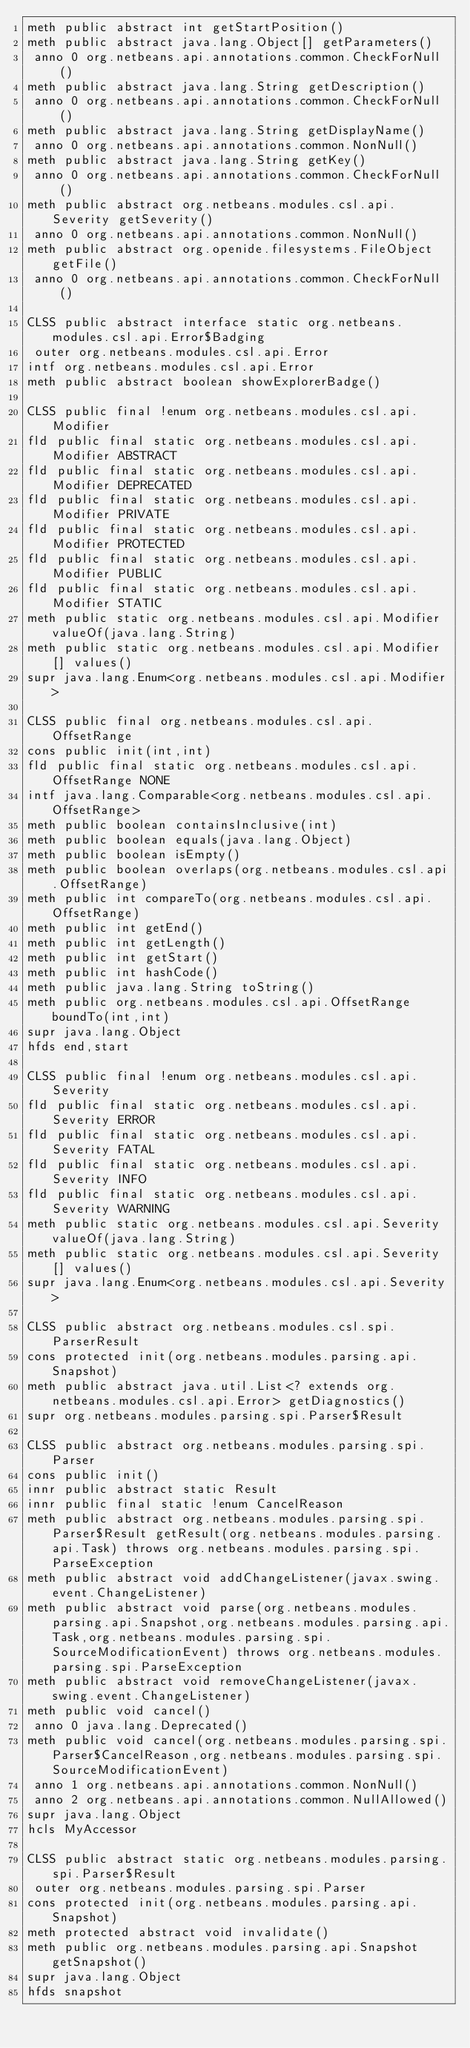Convert code to text. <code><loc_0><loc_0><loc_500><loc_500><_SML_>meth public abstract int getStartPosition()
meth public abstract java.lang.Object[] getParameters()
 anno 0 org.netbeans.api.annotations.common.CheckForNull()
meth public abstract java.lang.String getDescription()
 anno 0 org.netbeans.api.annotations.common.CheckForNull()
meth public abstract java.lang.String getDisplayName()
 anno 0 org.netbeans.api.annotations.common.NonNull()
meth public abstract java.lang.String getKey()
 anno 0 org.netbeans.api.annotations.common.CheckForNull()
meth public abstract org.netbeans.modules.csl.api.Severity getSeverity()
 anno 0 org.netbeans.api.annotations.common.NonNull()
meth public abstract org.openide.filesystems.FileObject getFile()
 anno 0 org.netbeans.api.annotations.common.CheckForNull()

CLSS public abstract interface static org.netbeans.modules.csl.api.Error$Badging
 outer org.netbeans.modules.csl.api.Error
intf org.netbeans.modules.csl.api.Error
meth public abstract boolean showExplorerBadge()

CLSS public final !enum org.netbeans.modules.csl.api.Modifier
fld public final static org.netbeans.modules.csl.api.Modifier ABSTRACT
fld public final static org.netbeans.modules.csl.api.Modifier DEPRECATED
fld public final static org.netbeans.modules.csl.api.Modifier PRIVATE
fld public final static org.netbeans.modules.csl.api.Modifier PROTECTED
fld public final static org.netbeans.modules.csl.api.Modifier PUBLIC
fld public final static org.netbeans.modules.csl.api.Modifier STATIC
meth public static org.netbeans.modules.csl.api.Modifier valueOf(java.lang.String)
meth public static org.netbeans.modules.csl.api.Modifier[] values()
supr java.lang.Enum<org.netbeans.modules.csl.api.Modifier>

CLSS public final org.netbeans.modules.csl.api.OffsetRange
cons public init(int,int)
fld public final static org.netbeans.modules.csl.api.OffsetRange NONE
intf java.lang.Comparable<org.netbeans.modules.csl.api.OffsetRange>
meth public boolean containsInclusive(int)
meth public boolean equals(java.lang.Object)
meth public boolean isEmpty()
meth public boolean overlaps(org.netbeans.modules.csl.api.OffsetRange)
meth public int compareTo(org.netbeans.modules.csl.api.OffsetRange)
meth public int getEnd()
meth public int getLength()
meth public int getStart()
meth public int hashCode()
meth public java.lang.String toString()
meth public org.netbeans.modules.csl.api.OffsetRange boundTo(int,int)
supr java.lang.Object
hfds end,start

CLSS public final !enum org.netbeans.modules.csl.api.Severity
fld public final static org.netbeans.modules.csl.api.Severity ERROR
fld public final static org.netbeans.modules.csl.api.Severity FATAL
fld public final static org.netbeans.modules.csl.api.Severity INFO
fld public final static org.netbeans.modules.csl.api.Severity WARNING
meth public static org.netbeans.modules.csl.api.Severity valueOf(java.lang.String)
meth public static org.netbeans.modules.csl.api.Severity[] values()
supr java.lang.Enum<org.netbeans.modules.csl.api.Severity>

CLSS public abstract org.netbeans.modules.csl.spi.ParserResult
cons protected init(org.netbeans.modules.parsing.api.Snapshot)
meth public abstract java.util.List<? extends org.netbeans.modules.csl.api.Error> getDiagnostics()
supr org.netbeans.modules.parsing.spi.Parser$Result

CLSS public abstract org.netbeans.modules.parsing.spi.Parser
cons public init()
innr public abstract static Result
innr public final static !enum CancelReason
meth public abstract org.netbeans.modules.parsing.spi.Parser$Result getResult(org.netbeans.modules.parsing.api.Task) throws org.netbeans.modules.parsing.spi.ParseException
meth public abstract void addChangeListener(javax.swing.event.ChangeListener)
meth public abstract void parse(org.netbeans.modules.parsing.api.Snapshot,org.netbeans.modules.parsing.api.Task,org.netbeans.modules.parsing.spi.SourceModificationEvent) throws org.netbeans.modules.parsing.spi.ParseException
meth public abstract void removeChangeListener(javax.swing.event.ChangeListener)
meth public void cancel()
 anno 0 java.lang.Deprecated()
meth public void cancel(org.netbeans.modules.parsing.spi.Parser$CancelReason,org.netbeans.modules.parsing.spi.SourceModificationEvent)
 anno 1 org.netbeans.api.annotations.common.NonNull()
 anno 2 org.netbeans.api.annotations.common.NullAllowed()
supr java.lang.Object
hcls MyAccessor

CLSS public abstract static org.netbeans.modules.parsing.spi.Parser$Result
 outer org.netbeans.modules.parsing.spi.Parser
cons protected init(org.netbeans.modules.parsing.api.Snapshot)
meth protected abstract void invalidate()
meth public org.netbeans.modules.parsing.api.Snapshot getSnapshot()
supr java.lang.Object
hfds snapshot

</code> 